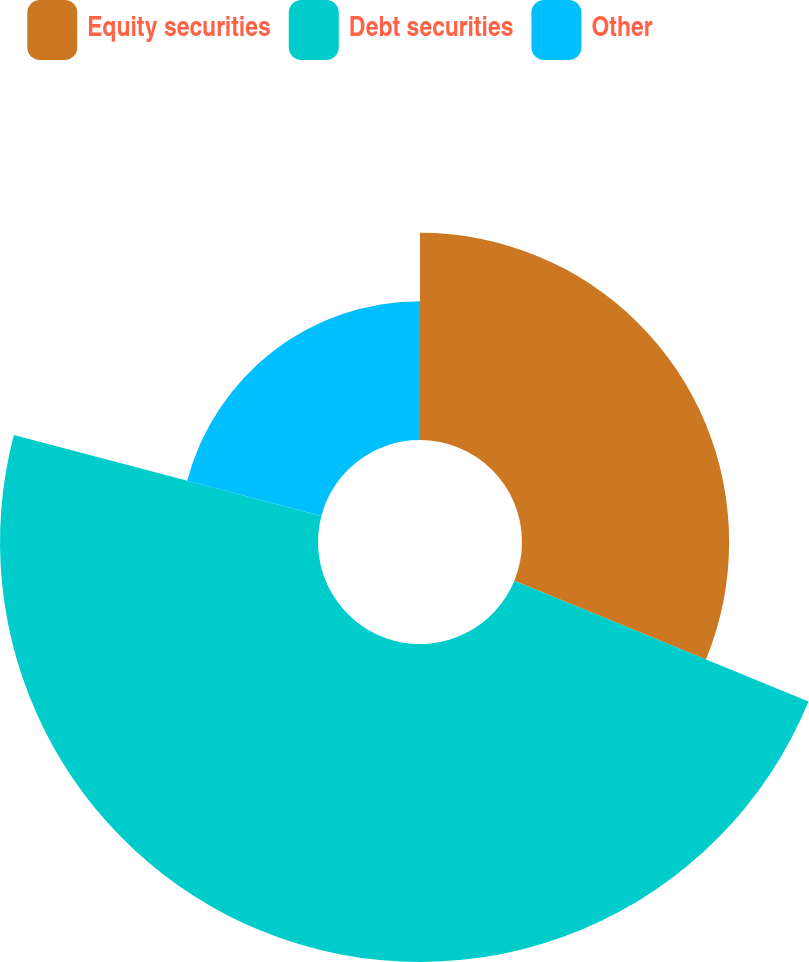Convert chart. <chart><loc_0><loc_0><loc_500><loc_500><pie_chart><fcel>Equity securities<fcel>Debt securities<fcel>Other<nl><fcel>31.2%<fcel>47.9%<fcel>20.9%<nl></chart> 